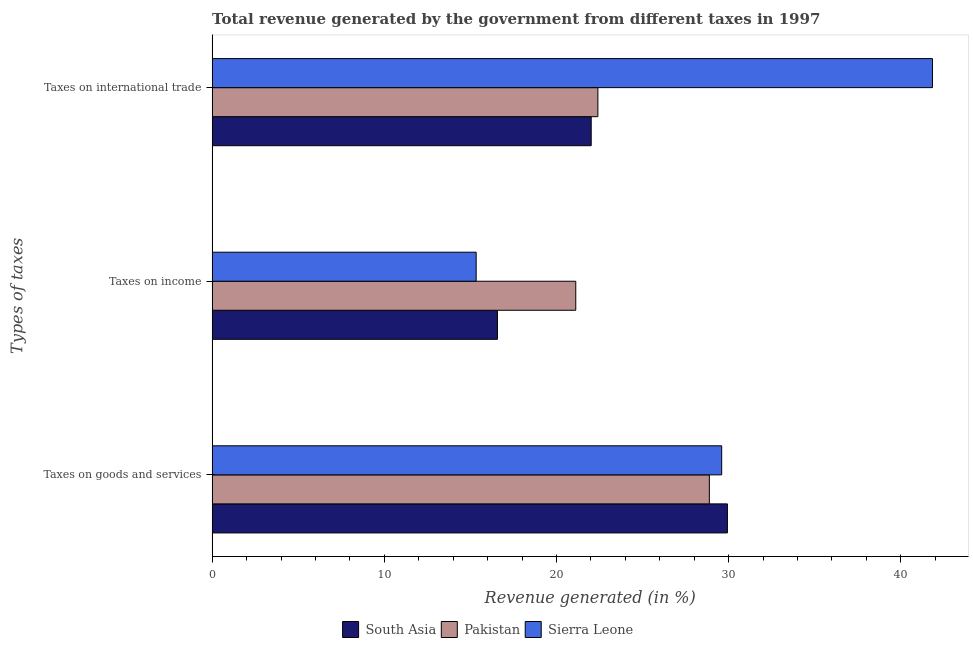How many different coloured bars are there?
Ensure brevity in your answer.  3. How many groups of bars are there?
Provide a short and direct response. 3. Are the number of bars on each tick of the Y-axis equal?
Provide a short and direct response. Yes. How many bars are there on the 1st tick from the bottom?
Offer a terse response. 3. What is the label of the 3rd group of bars from the top?
Ensure brevity in your answer.  Taxes on goods and services. What is the percentage of revenue generated by tax on international trade in South Asia?
Ensure brevity in your answer.  22.02. Across all countries, what is the maximum percentage of revenue generated by taxes on goods and services?
Make the answer very short. 29.93. Across all countries, what is the minimum percentage of revenue generated by taxes on income?
Offer a very short reply. 15.34. In which country was the percentage of revenue generated by taxes on goods and services maximum?
Offer a very short reply. South Asia. In which country was the percentage of revenue generated by taxes on income minimum?
Provide a succinct answer. Sierra Leone. What is the total percentage of revenue generated by taxes on goods and services in the graph?
Make the answer very short. 88.4. What is the difference between the percentage of revenue generated by taxes on income in South Asia and that in Pakistan?
Your answer should be compact. -4.55. What is the difference between the percentage of revenue generated by taxes on goods and services in Pakistan and the percentage of revenue generated by taxes on income in South Asia?
Offer a very short reply. 12.31. What is the average percentage of revenue generated by taxes on goods and services per country?
Offer a terse response. 29.47. What is the difference between the percentage of revenue generated by taxes on income and percentage of revenue generated by taxes on goods and services in Pakistan?
Keep it short and to the point. -7.76. What is the ratio of the percentage of revenue generated by taxes on income in Pakistan to that in Sierra Leone?
Provide a succinct answer. 1.38. Is the difference between the percentage of revenue generated by taxes on goods and services in South Asia and Sierra Leone greater than the difference between the percentage of revenue generated by tax on international trade in South Asia and Sierra Leone?
Your response must be concise. Yes. What is the difference between the highest and the second highest percentage of revenue generated by taxes on goods and services?
Offer a terse response. 0.33. What is the difference between the highest and the lowest percentage of revenue generated by taxes on income?
Give a very brief answer. 5.78. In how many countries, is the percentage of revenue generated by taxes on income greater than the average percentage of revenue generated by taxes on income taken over all countries?
Your answer should be very brief. 1. Is the sum of the percentage of revenue generated by taxes on income in Pakistan and South Asia greater than the maximum percentage of revenue generated by tax on international trade across all countries?
Offer a terse response. No. What does the 3rd bar from the bottom in Taxes on income represents?
Provide a succinct answer. Sierra Leone. Is it the case that in every country, the sum of the percentage of revenue generated by taxes on goods and services and percentage of revenue generated by taxes on income is greater than the percentage of revenue generated by tax on international trade?
Give a very brief answer. Yes. What is the difference between two consecutive major ticks on the X-axis?
Provide a succinct answer. 10. Are the values on the major ticks of X-axis written in scientific E-notation?
Your answer should be compact. No. Where does the legend appear in the graph?
Your answer should be compact. Bottom center. How are the legend labels stacked?
Your answer should be compact. Horizontal. What is the title of the graph?
Provide a succinct answer. Total revenue generated by the government from different taxes in 1997. Does "High income" appear as one of the legend labels in the graph?
Your response must be concise. No. What is the label or title of the X-axis?
Your response must be concise. Revenue generated (in %). What is the label or title of the Y-axis?
Keep it short and to the point. Types of taxes. What is the Revenue generated (in %) in South Asia in Taxes on goods and services?
Your answer should be very brief. 29.93. What is the Revenue generated (in %) in Pakistan in Taxes on goods and services?
Give a very brief answer. 28.88. What is the Revenue generated (in %) in Sierra Leone in Taxes on goods and services?
Offer a very short reply. 29.59. What is the Revenue generated (in %) of South Asia in Taxes on income?
Your answer should be very brief. 16.57. What is the Revenue generated (in %) of Pakistan in Taxes on income?
Give a very brief answer. 21.12. What is the Revenue generated (in %) in Sierra Leone in Taxes on income?
Provide a short and direct response. 15.34. What is the Revenue generated (in %) in South Asia in Taxes on international trade?
Keep it short and to the point. 22.02. What is the Revenue generated (in %) in Pakistan in Taxes on international trade?
Offer a very short reply. 22.4. What is the Revenue generated (in %) in Sierra Leone in Taxes on international trade?
Your answer should be compact. 41.84. Across all Types of taxes, what is the maximum Revenue generated (in %) of South Asia?
Provide a short and direct response. 29.93. Across all Types of taxes, what is the maximum Revenue generated (in %) in Pakistan?
Provide a short and direct response. 28.88. Across all Types of taxes, what is the maximum Revenue generated (in %) in Sierra Leone?
Keep it short and to the point. 41.84. Across all Types of taxes, what is the minimum Revenue generated (in %) of South Asia?
Provide a succinct answer. 16.57. Across all Types of taxes, what is the minimum Revenue generated (in %) in Pakistan?
Ensure brevity in your answer.  21.12. Across all Types of taxes, what is the minimum Revenue generated (in %) of Sierra Leone?
Your answer should be very brief. 15.34. What is the total Revenue generated (in %) of South Asia in the graph?
Ensure brevity in your answer.  68.51. What is the total Revenue generated (in %) of Pakistan in the graph?
Provide a succinct answer. 72.4. What is the total Revenue generated (in %) in Sierra Leone in the graph?
Your answer should be compact. 86.77. What is the difference between the Revenue generated (in %) of South Asia in Taxes on goods and services and that in Taxes on income?
Your response must be concise. 13.36. What is the difference between the Revenue generated (in %) in Pakistan in Taxes on goods and services and that in Taxes on income?
Provide a short and direct response. 7.76. What is the difference between the Revenue generated (in %) in Sierra Leone in Taxes on goods and services and that in Taxes on income?
Give a very brief answer. 14.26. What is the difference between the Revenue generated (in %) in South Asia in Taxes on goods and services and that in Taxes on international trade?
Offer a terse response. 7.91. What is the difference between the Revenue generated (in %) of Pakistan in Taxes on goods and services and that in Taxes on international trade?
Make the answer very short. 6.47. What is the difference between the Revenue generated (in %) of Sierra Leone in Taxes on goods and services and that in Taxes on international trade?
Offer a terse response. -12.24. What is the difference between the Revenue generated (in %) of South Asia in Taxes on income and that in Taxes on international trade?
Provide a succinct answer. -5.45. What is the difference between the Revenue generated (in %) of Pakistan in Taxes on income and that in Taxes on international trade?
Offer a terse response. -1.29. What is the difference between the Revenue generated (in %) in Sierra Leone in Taxes on income and that in Taxes on international trade?
Your response must be concise. -26.5. What is the difference between the Revenue generated (in %) of South Asia in Taxes on goods and services and the Revenue generated (in %) of Pakistan in Taxes on income?
Offer a terse response. 8.81. What is the difference between the Revenue generated (in %) in South Asia in Taxes on goods and services and the Revenue generated (in %) in Sierra Leone in Taxes on income?
Ensure brevity in your answer.  14.59. What is the difference between the Revenue generated (in %) of Pakistan in Taxes on goods and services and the Revenue generated (in %) of Sierra Leone in Taxes on income?
Your answer should be compact. 13.54. What is the difference between the Revenue generated (in %) in South Asia in Taxes on goods and services and the Revenue generated (in %) in Pakistan in Taxes on international trade?
Make the answer very short. 7.52. What is the difference between the Revenue generated (in %) in South Asia in Taxes on goods and services and the Revenue generated (in %) in Sierra Leone in Taxes on international trade?
Offer a very short reply. -11.91. What is the difference between the Revenue generated (in %) of Pakistan in Taxes on goods and services and the Revenue generated (in %) of Sierra Leone in Taxes on international trade?
Make the answer very short. -12.96. What is the difference between the Revenue generated (in %) of South Asia in Taxes on income and the Revenue generated (in %) of Pakistan in Taxes on international trade?
Keep it short and to the point. -5.83. What is the difference between the Revenue generated (in %) of South Asia in Taxes on income and the Revenue generated (in %) of Sierra Leone in Taxes on international trade?
Ensure brevity in your answer.  -25.27. What is the difference between the Revenue generated (in %) of Pakistan in Taxes on income and the Revenue generated (in %) of Sierra Leone in Taxes on international trade?
Keep it short and to the point. -20.72. What is the average Revenue generated (in %) in South Asia per Types of taxes?
Your answer should be very brief. 22.84. What is the average Revenue generated (in %) of Pakistan per Types of taxes?
Ensure brevity in your answer.  24.13. What is the average Revenue generated (in %) of Sierra Leone per Types of taxes?
Provide a succinct answer. 28.92. What is the difference between the Revenue generated (in %) in South Asia and Revenue generated (in %) in Pakistan in Taxes on goods and services?
Give a very brief answer. 1.05. What is the difference between the Revenue generated (in %) of South Asia and Revenue generated (in %) of Sierra Leone in Taxes on goods and services?
Ensure brevity in your answer.  0.33. What is the difference between the Revenue generated (in %) of Pakistan and Revenue generated (in %) of Sierra Leone in Taxes on goods and services?
Your answer should be compact. -0.72. What is the difference between the Revenue generated (in %) in South Asia and Revenue generated (in %) in Pakistan in Taxes on income?
Keep it short and to the point. -4.55. What is the difference between the Revenue generated (in %) of South Asia and Revenue generated (in %) of Sierra Leone in Taxes on income?
Offer a very short reply. 1.23. What is the difference between the Revenue generated (in %) in Pakistan and Revenue generated (in %) in Sierra Leone in Taxes on income?
Ensure brevity in your answer.  5.78. What is the difference between the Revenue generated (in %) of South Asia and Revenue generated (in %) of Pakistan in Taxes on international trade?
Your response must be concise. -0.39. What is the difference between the Revenue generated (in %) in South Asia and Revenue generated (in %) in Sierra Leone in Taxes on international trade?
Your response must be concise. -19.82. What is the difference between the Revenue generated (in %) of Pakistan and Revenue generated (in %) of Sierra Leone in Taxes on international trade?
Ensure brevity in your answer.  -19.43. What is the ratio of the Revenue generated (in %) in South Asia in Taxes on goods and services to that in Taxes on income?
Your answer should be compact. 1.81. What is the ratio of the Revenue generated (in %) of Pakistan in Taxes on goods and services to that in Taxes on income?
Your response must be concise. 1.37. What is the ratio of the Revenue generated (in %) of Sierra Leone in Taxes on goods and services to that in Taxes on income?
Keep it short and to the point. 1.93. What is the ratio of the Revenue generated (in %) of South Asia in Taxes on goods and services to that in Taxes on international trade?
Your answer should be compact. 1.36. What is the ratio of the Revenue generated (in %) of Pakistan in Taxes on goods and services to that in Taxes on international trade?
Offer a very short reply. 1.29. What is the ratio of the Revenue generated (in %) in Sierra Leone in Taxes on goods and services to that in Taxes on international trade?
Offer a terse response. 0.71. What is the ratio of the Revenue generated (in %) in South Asia in Taxes on income to that in Taxes on international trade?
Give a very brief answer. 0.75. What is the ratio of the Revenue generated (in %) in Pakistan in Taxes on income to that in Taxes on international trade?
Offer a very short reply. 0.94. What is the ratio of the Revenue generated (in %) of Sierra Leone in Taxes on income to that in Taxes on international trade?
Give a very brief answer. 0.37. What is the difference between the highest and the second highest Revenue generated (in %) of South Asia?
Your answer should be very brief. 7.91. What is the difference between the highest and the second highest Revenue generated (in %) of Pakistan?
Your answer should be compact. 6.47. What is the difference between the highest and the second highest Revenue generated (in %) in Sierra Leone?
Keep it short and to the point. 12.24. What is the difference between the highest and the lowest Revenue generated (in %) of South Asia?
Provide a short and direct response. 13.36. What is the difference between the highest and the lowest Revenue generated (in %) of Pakistan?
Provide a short and direct response. 7.76. What is the difference between the highest and the lowest Revenue generated (in %) of Sierra Leone?
Your answer should be very brief. 26.5. 